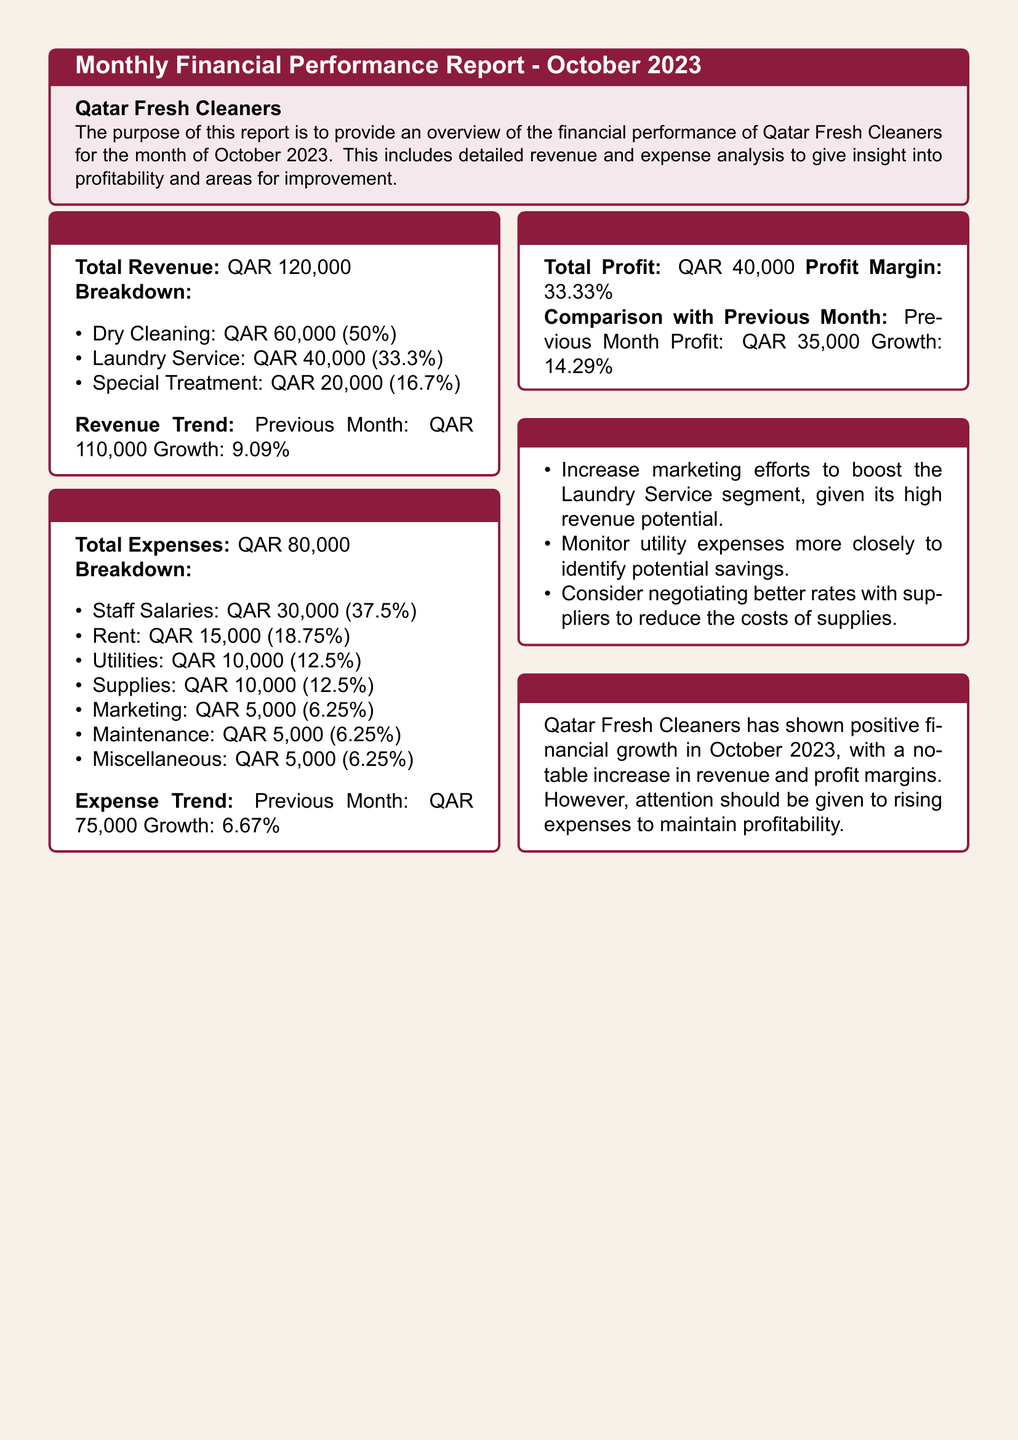What is the total revenue? The total revenue is the total amount earned from all services provided by Qatar Fresh Cleaners in October 2023, which amounts to QAR 120,000.
Answer: QAR 120,000 What is the revenue from Laundry Service? The revenue from Laundry Service is detailed in the breakdown section of the revenue analysis, which states it is QAR 40,000.
Answer: QAR 40,000 What was the percentage growth in revenue compared to the previous month? The document states that the growth compared to the previous month was 9.09%.
Answer: 9.09% What is the total profit for October 2023? The total profit is calculated as total revenue minus total expenses, which equals QAR 40,000 according to the profit analysis.
Answer: QAR 40,000 What category accounts for the highest expense? Among the listed expenses, Staff Salaries has the highest amount at QAR 30,000, mentioned in the expense breakdown.
Answer: Staff Salaries What was the previous month's profit? The comparison with the previous month shows a profit of QAR 35,000, as stated in the profit analysis section.
Answer: QAR 35,000 Which segment has a recommendation to increase marketing efforts? The recommendations indicate that the Laundry Service segment has a high revenue potential and suggests increasing marketing efforts directed towards it.
Answer: Laundry Service What was the growth rate in expenses compared to the previous month? The document mentions that the growth in expenses from the previous month is 6.67%, which requires comparing the current and past expense values.
Answer: 6.67% What is the profit margin for October 2023? The profit margin is calculated and stated as 33.33% in the profit analysis section of the document.
Answer: 33.33% 